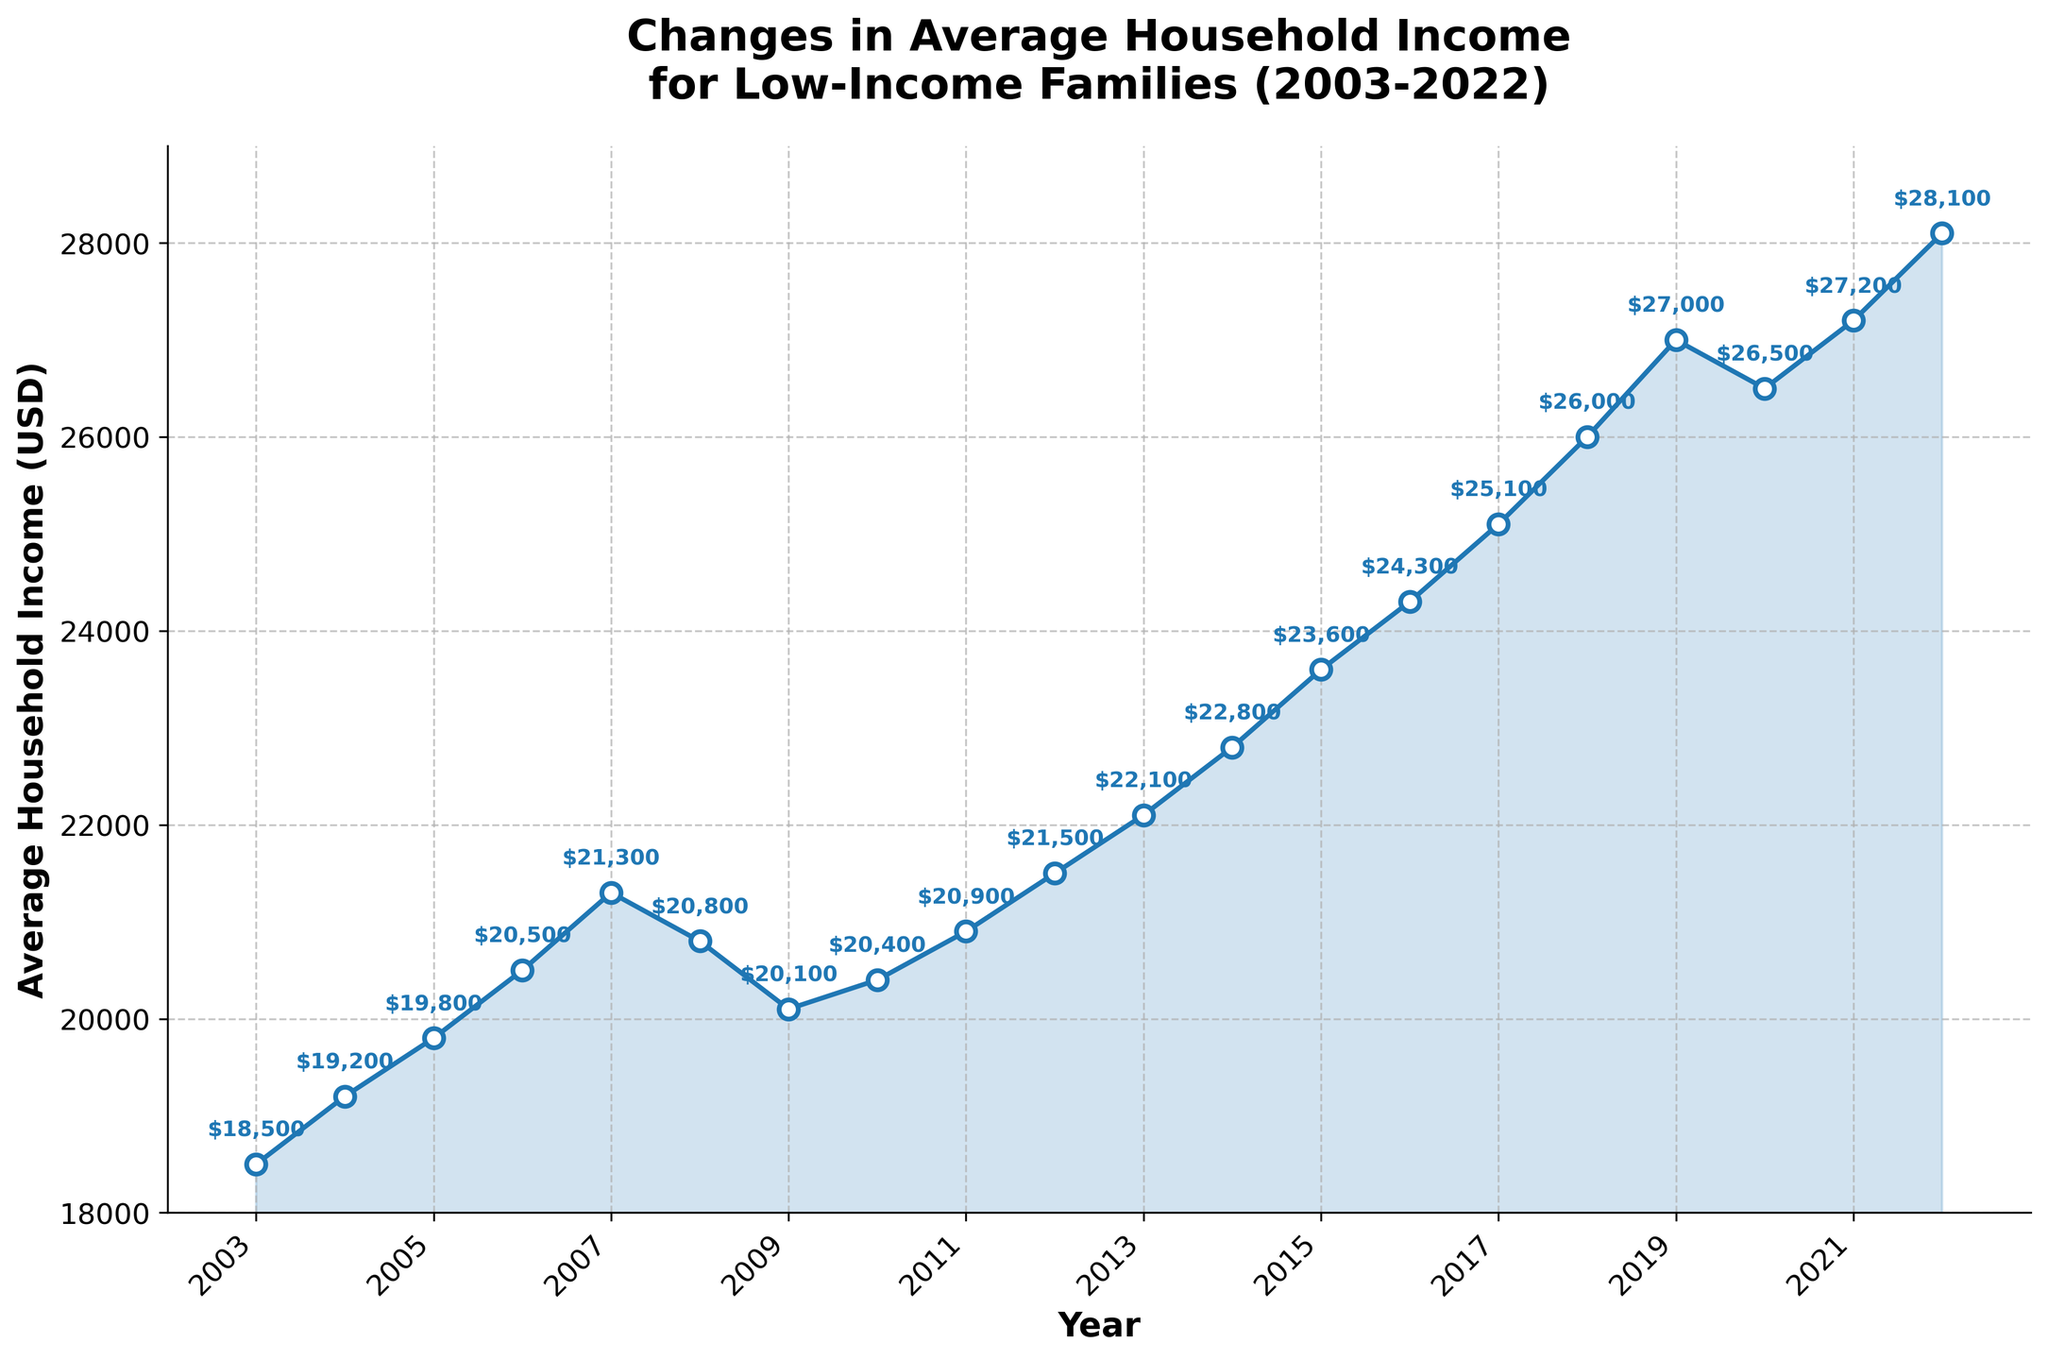What is the trend in average household income from 2003 to 2022? The figure shows a general upward trend in average household income over the years. Specific years where it dips slightly can be seen as exceptions, but the overall movement is towards an increase. Most years show a rise in income, peaking in 2022.
Answer: Upward trend In which year did the average household income first exceed $20,000? Looking at the plotted data points on the line chart, the first year the income exceeds $20,000 is 2006 with an income of $20,500.
Answer: 2006 By how much did the average household income increase from 2003 to 2022? The initial income in 2003 was $18,500, and by 2022 it increased to $28,100. The increase is determined by the difference 28,100 - 18,500 = 9,600.
Answer: $9,600 Between which consecutive years did the average household income experience the greatest decrease? Observing the line chart, the largest decrease occurred between 2019 and 2020, where the income fell from $27,000 to $26,500. It's a notable dip compared to other years.
Answer: 2019-2020 What was the average annual growth rate in household income from 2003 to 2022? The total increase over 19 years is $9,600. The annual growth rate can be found by dividing the total increase by the number of years: 9,600/19 ≈ 505.26. This indicates an approximate annual growth rate of $505.26.
Answer: $505.26 How many times did the average household income decrease compared to the previous year during the 20-year period? By tracking the points on the line chart where there's a decrease from the previous year, it's evident that there are 4 such years: 2008 to 2009, 2019 to 2020.
Answer: 2 times Compare the average household incomes of 2010 and 2020. Which year had a higher income and by how much? The average household income in 2010 was $20,400, and in 2020 it was $26,500. The difference is 26,500 - 20,400 = 6,100, with 2020 having the higher income.
Answer: 2020 by $6,100 What is the average income for the first ten years (2003-2012)? Adding the incomes from 2003 to 2012 gives a sum of (18,500 + 19,200 + 19,800 + 20,500 + 21,300 + 20,800 + 20,100 + 20,400 + 20,900 + 21,500) = 202,000. Dividing this sum by 10 yields 202,000/10 = 20,200.
Answer: $20,200 How does the income in 2022 compare visually to the peak income in the previous years? Observing the figure, 2022 shows the highest point on the chart, indicating that 2022 has the peak income compared to all previous years, visually standing out as the highest point on the line plot.
Answer: Highest point 